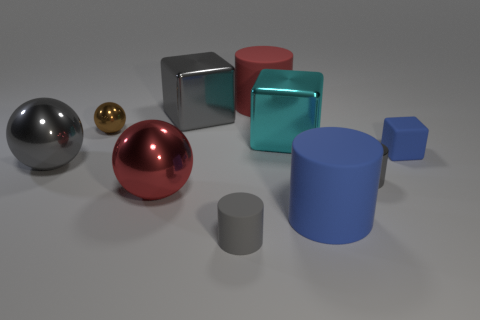Subtract all cylinders. How many objects are left? 6 Add 7 small brown metallic balls. How many small brown metallic balls exist? 8 Subtract 0 brown cylinders. How many objects are left? 10 Subtract all cyan blocks. Subtract all large red rubber things. How many objects are left? 8 Add 9 tiny gray metal cylinders. How many tiny gray metal cylinders are left? 10 